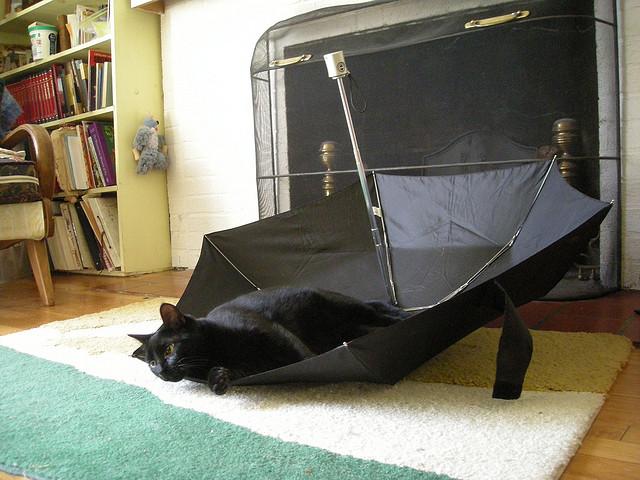What color is the rug?
Quick response, please. Yellow, white, blue. Is the fireplace lit with an active fire?
Short answer required. No. What is the cat laying on?
Concise answer only. Umbrella. 